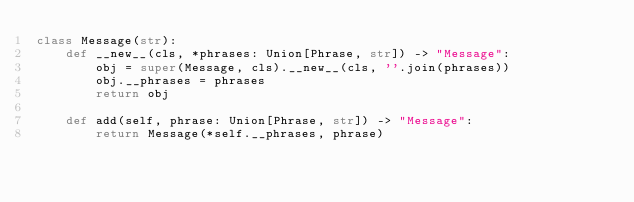<code> <loc_0><loc_0><loc_500><loc_500><_Python_>class Message(str):
    def __new__(cls, *phrases: Union[Phrase, str]) -> "Message":
        obj = super(Message, cls).__new__(cls, ''.join(phrases))
        obj.__phrases = phrases
        return obj

    def add(self, phrase: Union[Phrase, str]) -> "Message":
        return Message(*self.__phrases, phrase)
</code> 